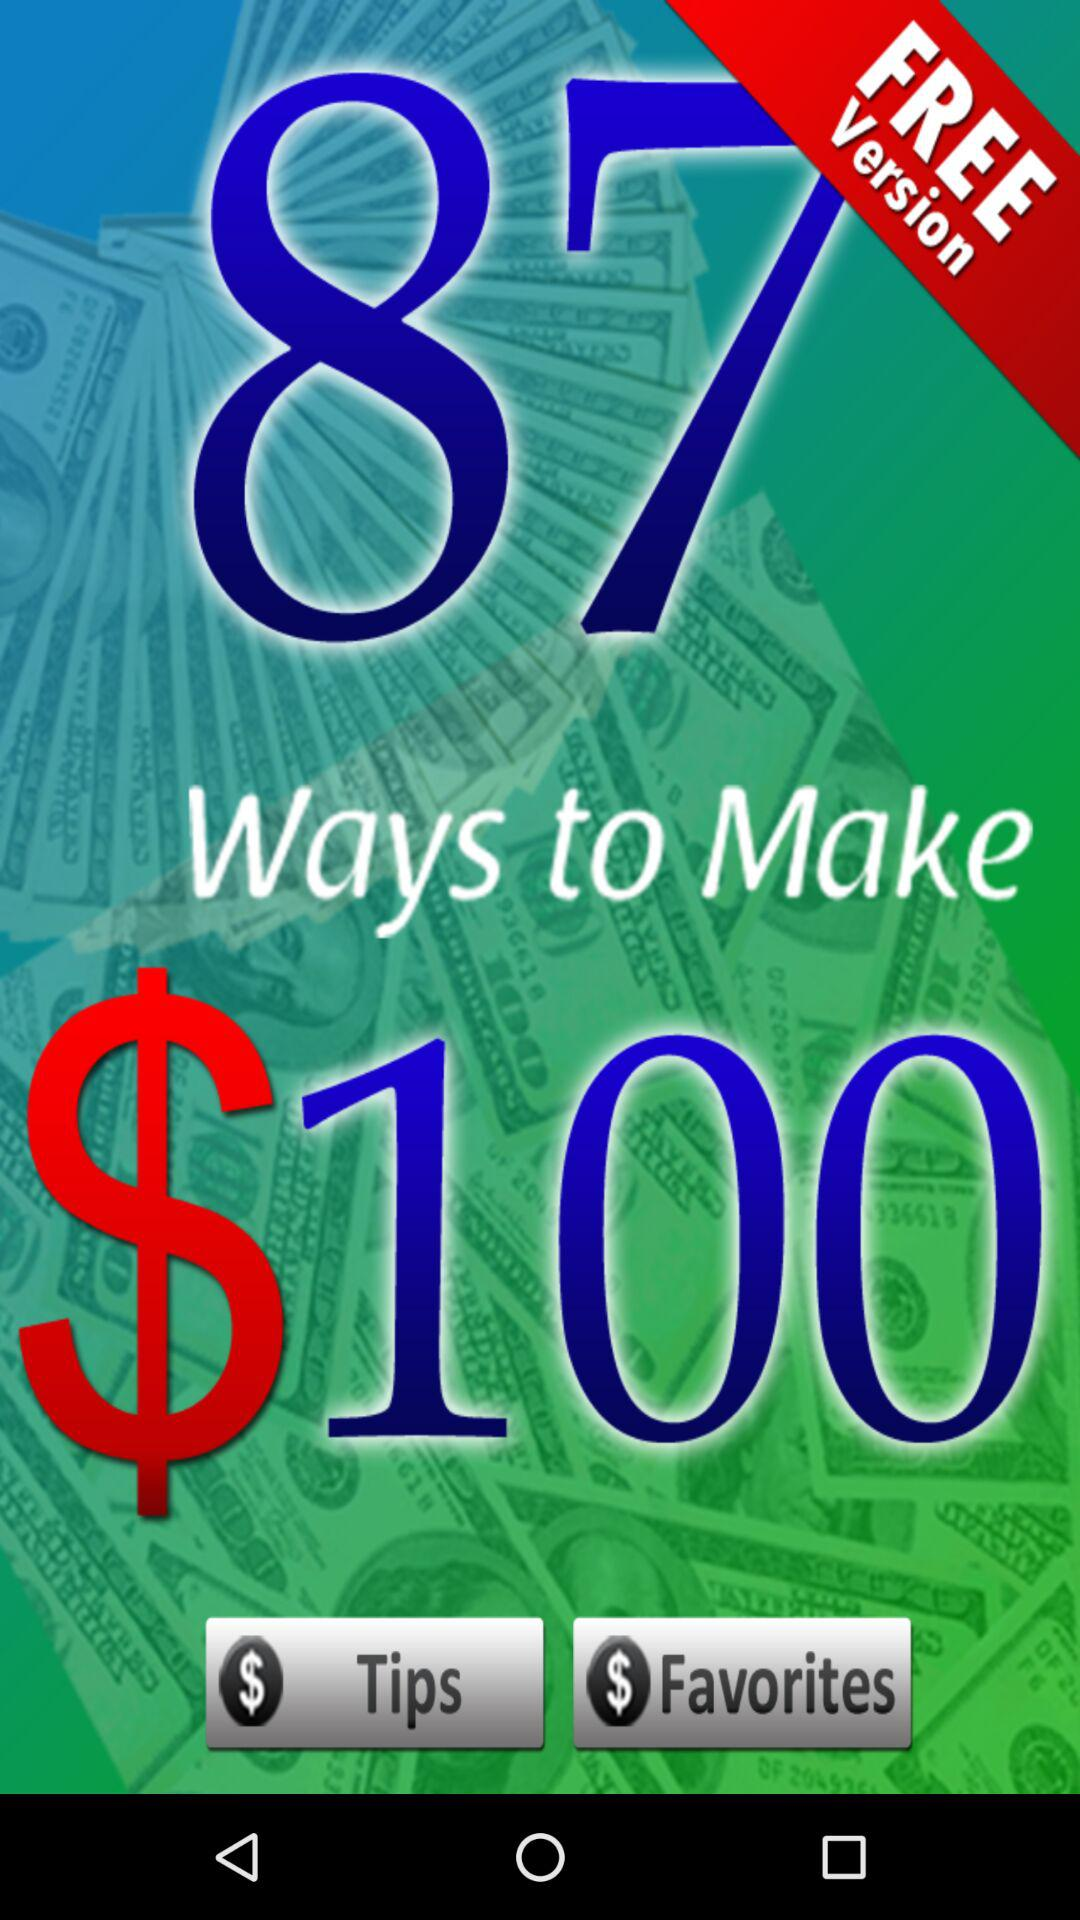What is the name of the application?
When the provided information is insufficient, respond with <no answer>. <no answer> 